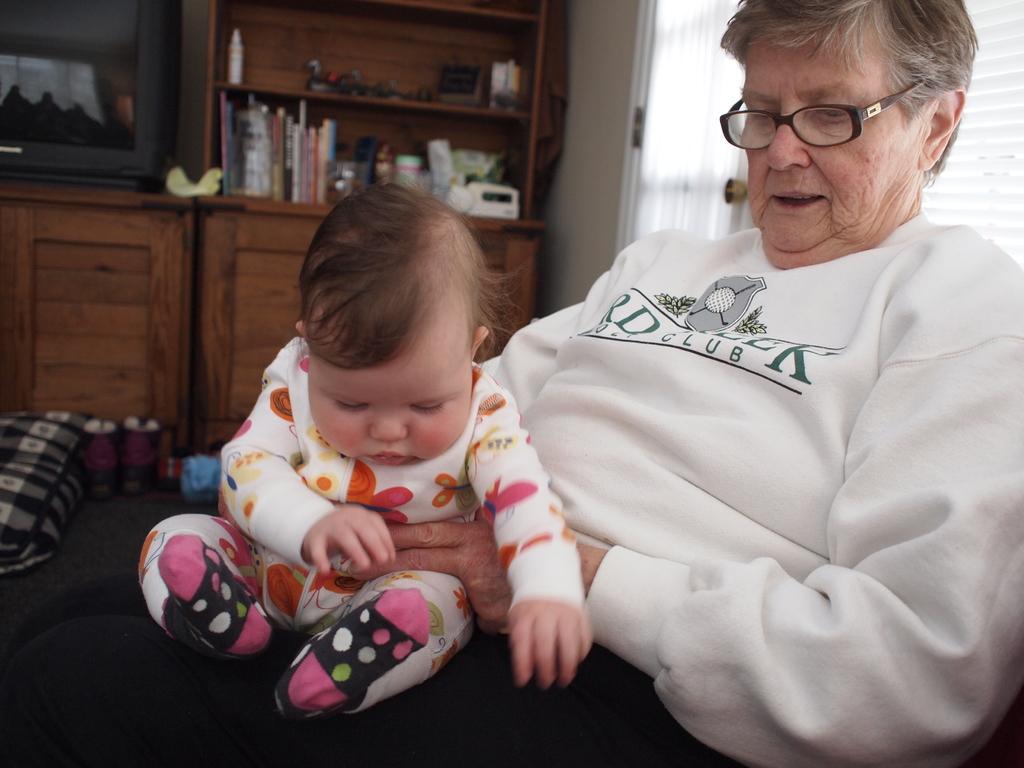Describe this image in one or two sentences. In this image I can see a woman and I can see she is holding a baby. I can see she is wearing white colour dress and a specs. On her dress I can see something is written and I can see this baby is wearing white colour dress. In the background I can see a television and number of things on the shelves. On the left side of this image I can see few stuffs on the floor. 